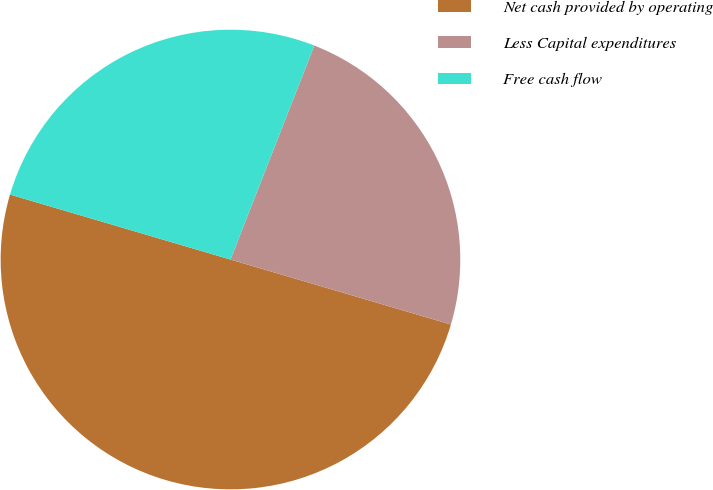Convert chart. <chart><loc_0><loc_0><loc_500><loc_500><pie_chart><fcel>Net cash provided by operating<fcel>Less Capital expenditures<fcel>Free cash flow<nl><fcel>50.0%<fcel>23.62%<fcel>26.38%<nl></chart> 